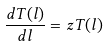Convert formula to latex. <formula><loc_0><loc_0><loc_500><loc_500>\frac { d T ( l ) } { d l } = z T ( l )</formula> 